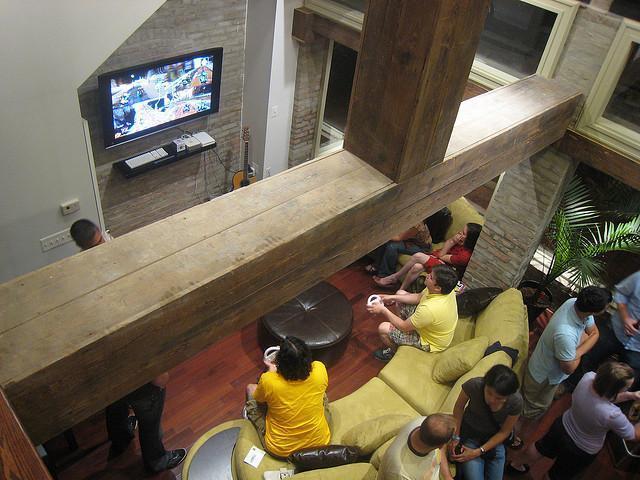How many people are sitting on the back of the couch?
Give a very brief answer. 2. How many people are visible?
Give a very brief answer. 9. 